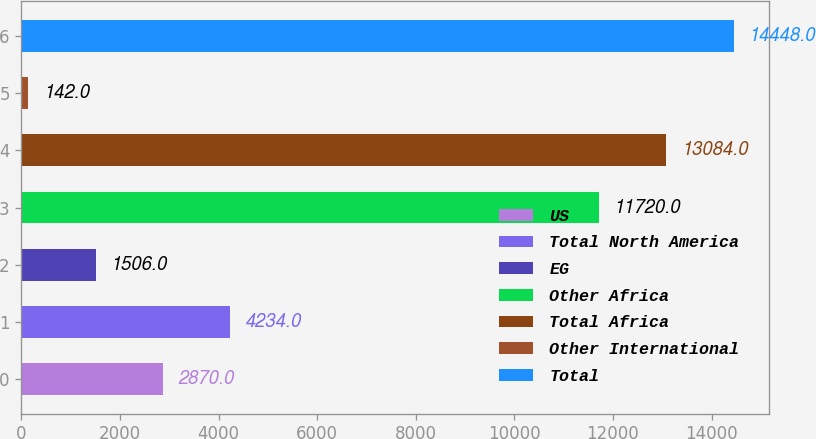Convert chart to OTSL. <chart><loc_0><loc_0><loc_500><loc_500><bar_chart><fcel>US<fcel>Total North America<fcel>EG<fcel>Other Africa<fcel>Total Africa<fcel>Other International<fcel>Total<nl><fcel>2870<fcel>4234<fcel>1506<fcel>11720<fcel>13084<fcel>142<fcel>14448<nl></chart> 